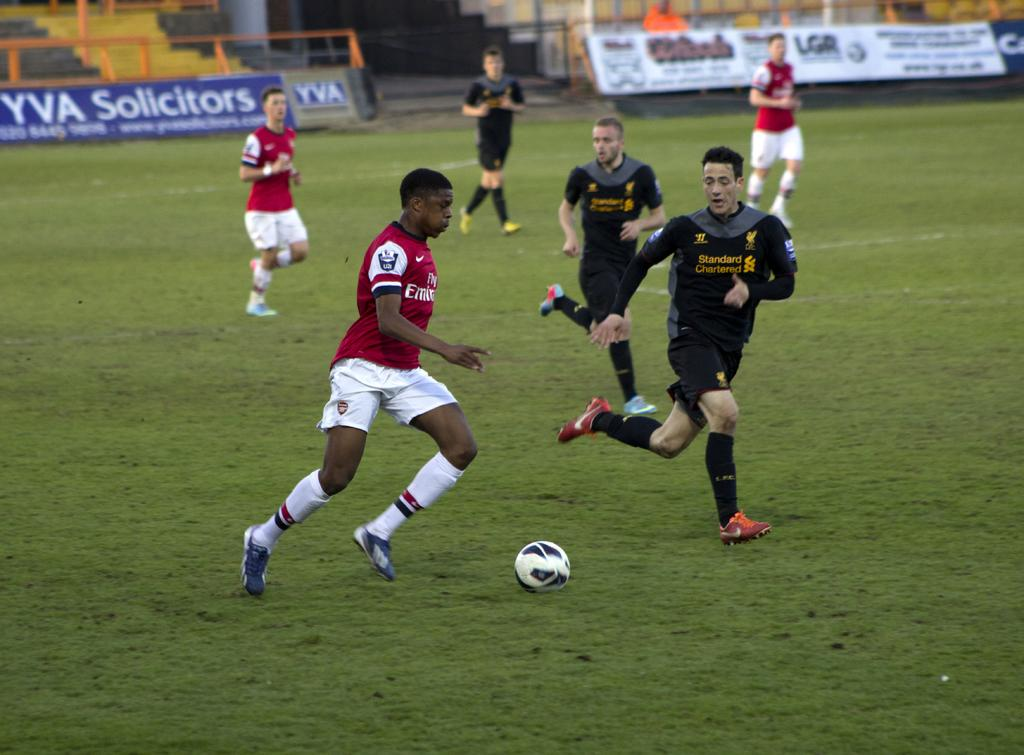What are the people in the image doing? The people in the image are running. What is on the ground where the people are running? There is grass on the ground, and there is also a ball on the ground. What can be seen in the background of the image? There are banners in the background, and something is written on the banners. Are there any architectural features visible in the background? Yes, there are steps in the background. How high is the kite flying in the image? There is no kite present in the image. Where is the shelf located in the image? There is no shelf present in the image. 